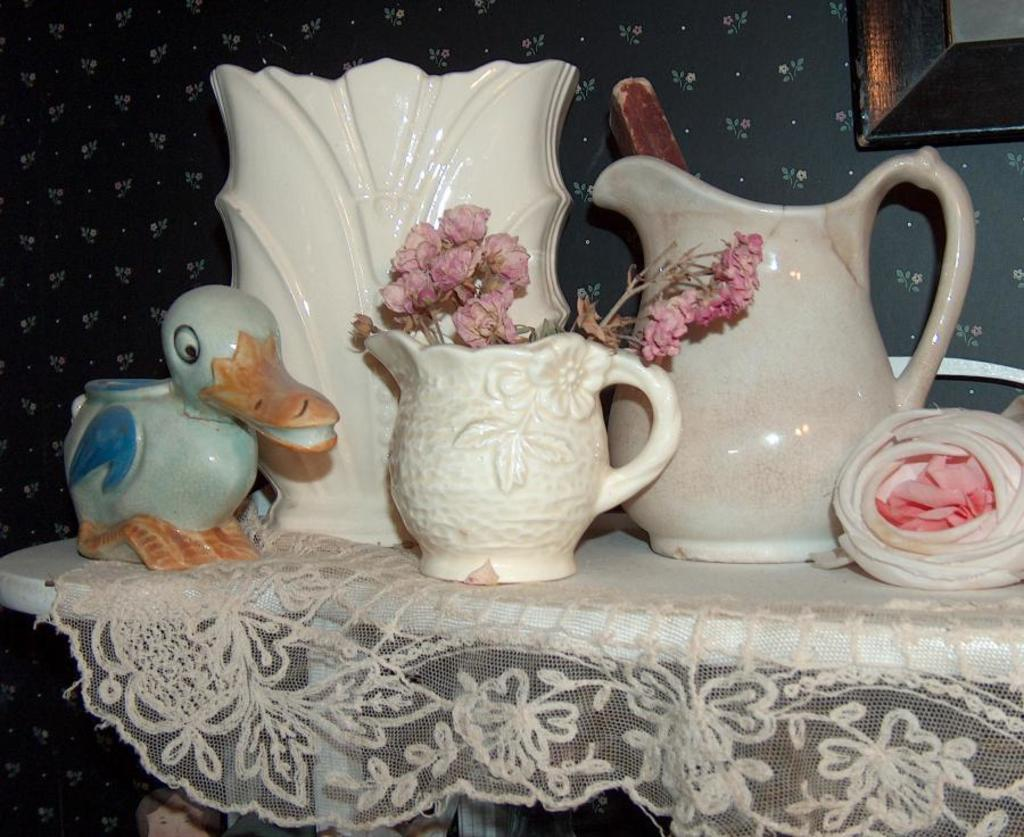What type of objects are made of ceramic in the image? There are ceramic pots and a ceramic toy in the image. What is growing in one of the ceramic pots? Flowers are present in one of the ceramic pots. What type of material is used for the cloth in the image? The cloth in the image is a net cloth. What color is the net cloth? The net cloth is white in color. What can be seen in the background of the image? There is a wall visible in the image. How many pears are hanging from the wall in the image? There are no pears present in the image; only ceramic pots, a ceramic toy, a net cloth, and a wall are visible. What type of metal is the zinc toy made of in the image? There is no zinc toy present in the image; it is a ceramic toy, not a zinc toy. 